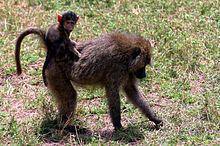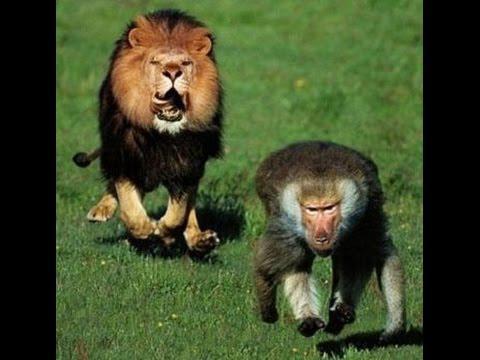The first image is the image on the left, the second image is the image on the right. Analyze the images presented: Is the assertion "There are no felines in the images." valid? Answer yes or no. No. The first image is the image on the left, the second image is the image on the right. Evaluate the accuracy of this statement regarding the images: "In one of the images there is a primate in close proximity to a large, wild cat.". Is it true? Answer yes or no. Yes. 